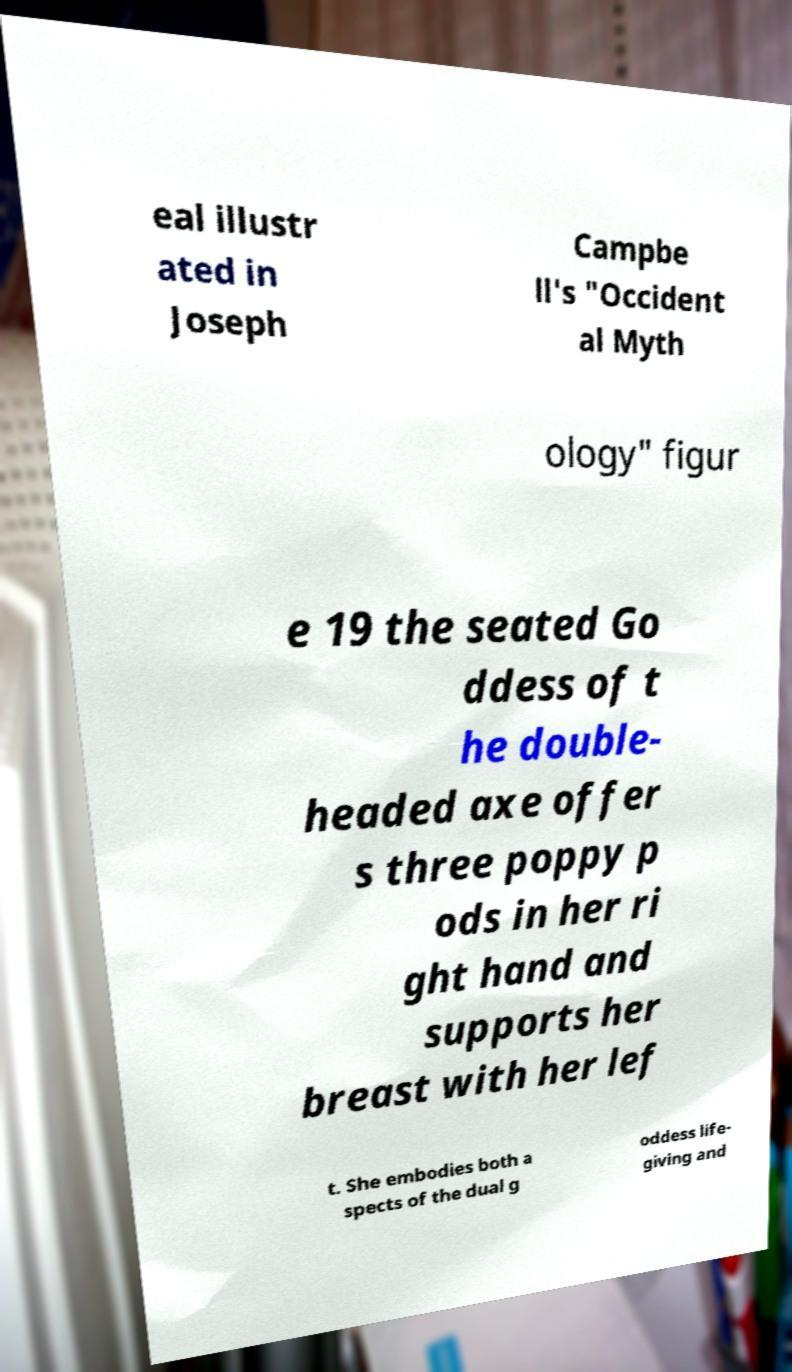Please identify and transcribe the text found in this image. eal illustr ated in Joseph Campbe ll's "Occident al Myth ology" figur e 19 the seated Go ddess of t he double- headed axe offer s three poppy p ods in her ri ght hand and supports her breast with her lef t. She embodies both a spects of the dual g oddess life- giving and 